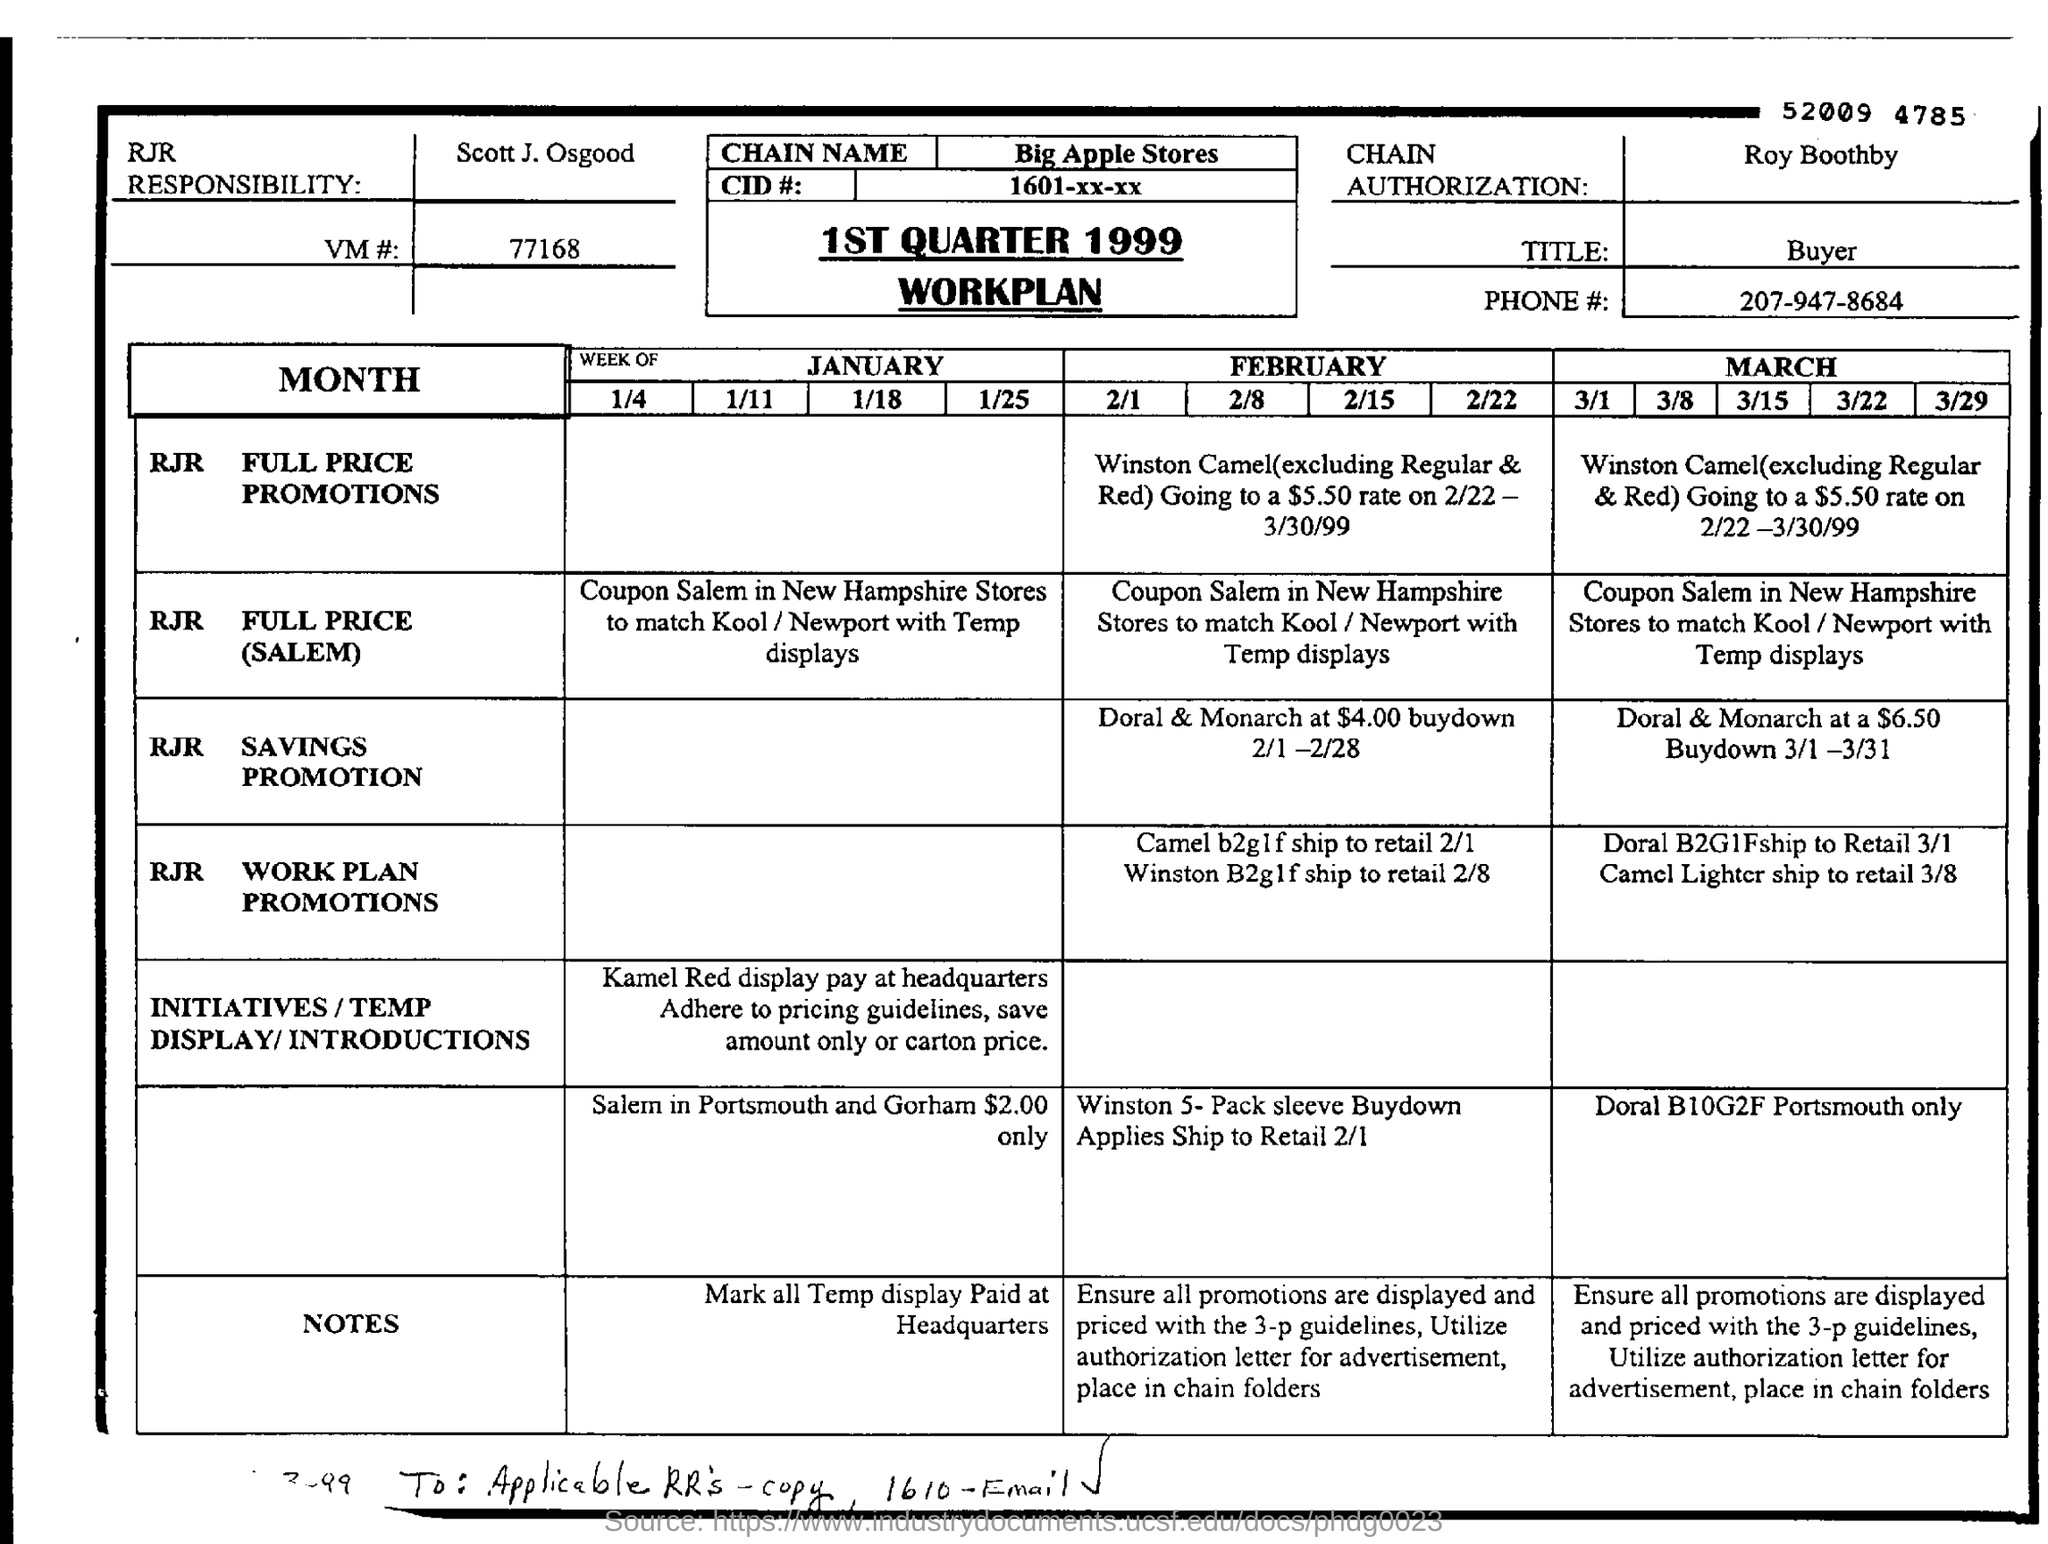Mention a couple of crucial points in this snapshot. Roy Boothby is mentioned in the Chain Authorization. The name of the workplan is the 1ST QUARTER 1999 WORKPLAN. The title mentioned is 'buyer.' The phone number mentioned is 207-947-8684. 